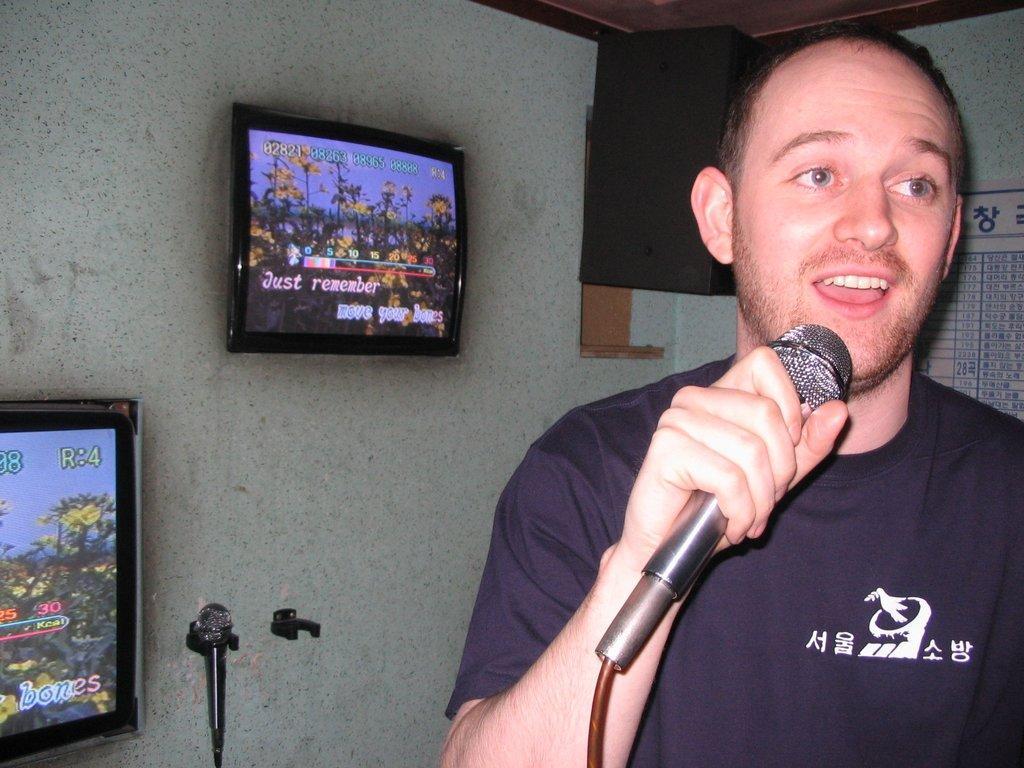Can you describe this image briefly? Here he is a man holding a microphone singing with his microphone. On the left side on image there is a wall. There are two people and two tv screens. n 